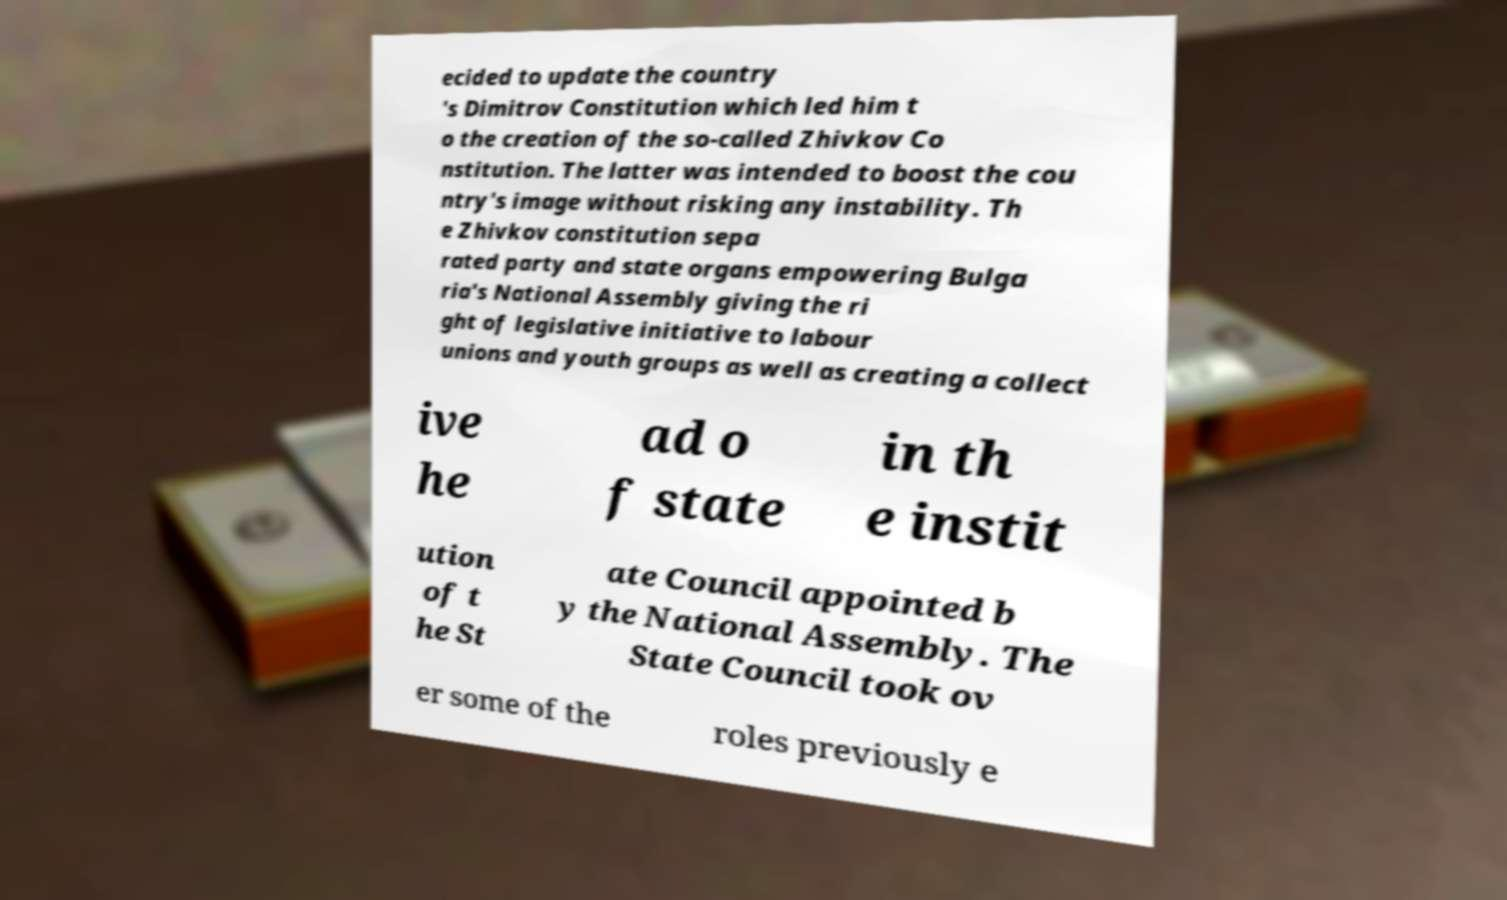Please read and relay the text visible in this image. What does it say? ecided to update the country 's Dimitrov Constitution which led him t o the creation of the so-called Zhivkov Co nstitution. The latter was intended to boost the cou ntry's image without risking any instability. Th e Zhivkov constitution sepa rated party and state organs empowering Bulga ria's National Assembly giving the ri ght of legislative initiative to labour unions and youth groups as well as creating a collect ive he ad o f state in th e instit ution of t he St ate Council appointed b y the National Assembly. The State Council took ov er some of the roles previously e 